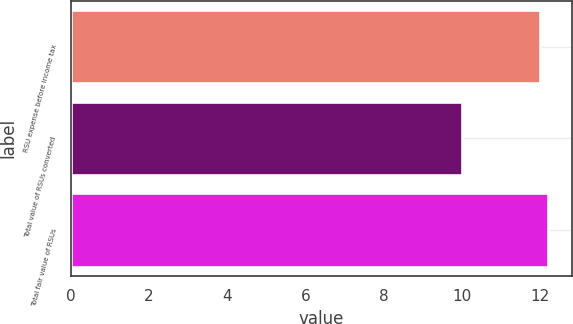Convert chart. <chart><loc_0><loc_0><loc_500><loc_500><bar_chart><fcel>RSU expense before income tax<fcel>Total value of RSUs converted<fcel>Total fair value of RSUs<nl><fcel>12<fcel>10<fcel>12.2<nl></chart> 